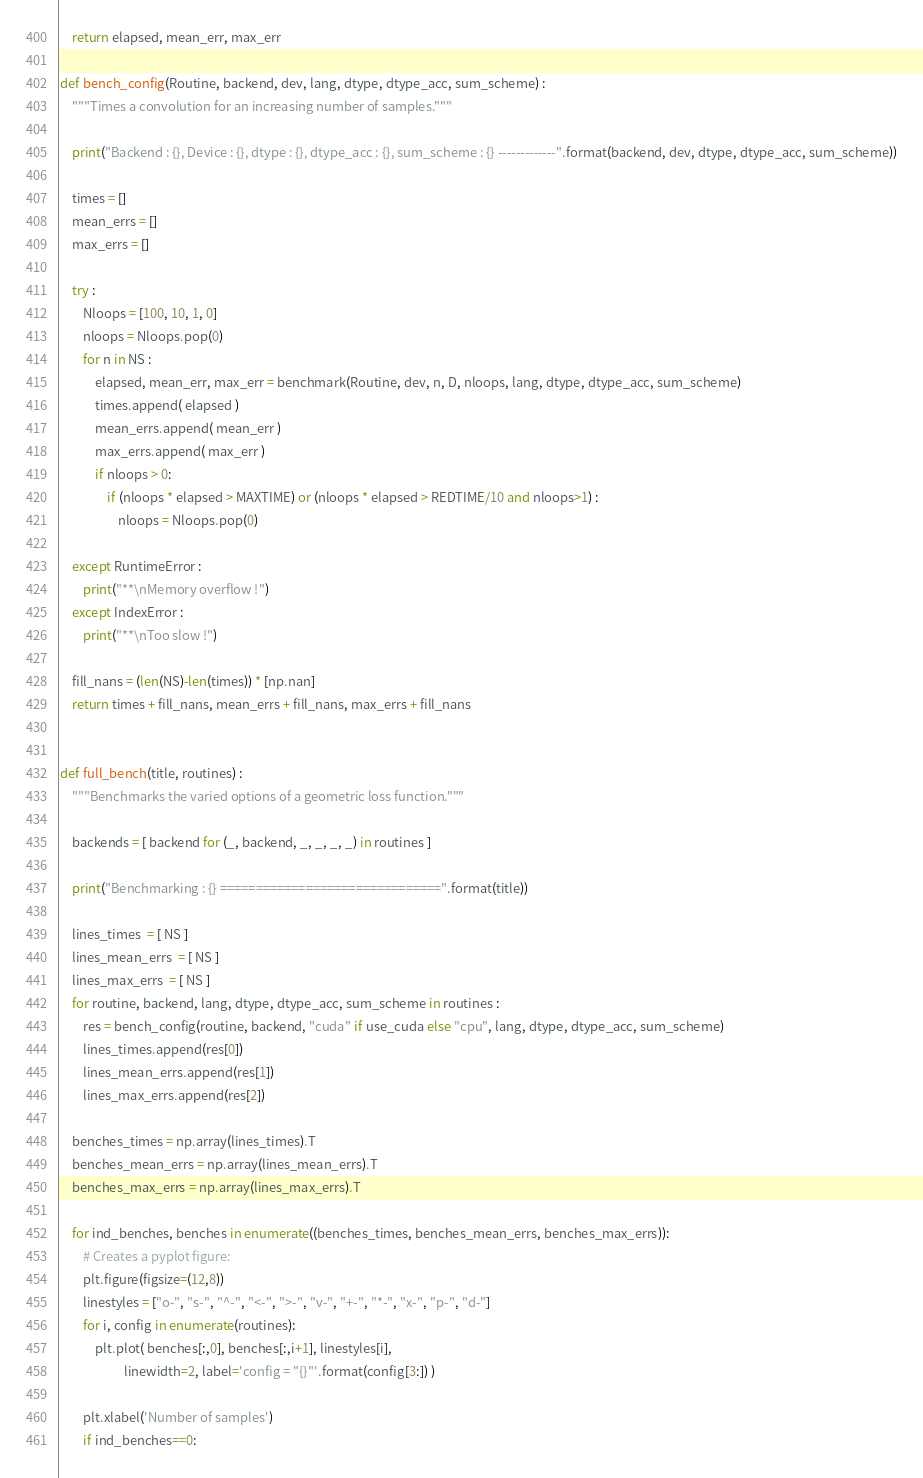Convert code to text. <code><loc_0><loc_0><loc_500><loc_500><_Python_>
    return elapsed, mean_err, max_err

def bench_config(Routine, backend, dev, lang, dtype, dtype_acc, sum_scheme) :
    """Times a convolution for an increasing number of samples."""

    print("Backend : {}, Device : {}, dtype : {}, dtype_acc : {}, sum_scheme : {} -------------".format(backend, dev, dtype, dtype_acc, sum_scheme))

    times = []
    mean_errs = []
    max_errs = []
            
    try :
        Nloops = [100, 10, 1, 0]
        nloops = Nloops.pop(0)
        for n in NS :
            elapsed, mean_err, max_err = benchmark(Routine, dev, n, D, nloops, lang, dtype, dtype_acc, sum_scheme)
            times.append( elapsed )
            mean_errs.append( mean_err )
            max_errs.append( max_err )
            if nloops > 0:
                if (nloops * elapsed > MAXTIME) or (nloops * elapsed > REDTIME/10 and nloops>1) : 
                    nloops = Nloops.pop(0)

    except RuntimeError :
        print("**\nMemory overflow !")
    except IndexError :
        print("**\nToo slow !")
    
    fill_nans = (len(NS)-len(times)) * [np.nan]
    return times + fill_nans, mean_errs + fill_nans, max_errs + fill_nans


def full_bench(title, routines) :
    """Benchmarks the varied options of a geometric loss function."""

    backends = [ backend for (_, backend, _, _, _, _) in routines ]

    print("Benchmarking : {} ===============================".format(title))
    
    lines_times  = [ NS ]
    lines_mean_errs  = [ NS ]
    lines_max_errs  = [ NS ]
    for routine, backend, lang, dtype, dtype_acc, sum_scheme in routines :
        res = bench_config(routine, backend, "cuda" if use_cuda else "cpu", lang, dtype, dtype_acc, sum_scheme)
        lines_times.append(res[0])
        lines_mean_errs.append(res[1])
        lines_max_errs.append(res[2])

    benches_times = np.array(lines_times).T
    benches_mean_errs = np.array(lines_mean_errs).T
    benches_max_errs = np.array(lines_max_errs).T

    for ind_benches, benches in enumerate((benches_times, benches_mean_errs, benches_max_errs)):
        # Creates a pyplot figure:
        plt.figure(figsize=(12,8))
        linestyles = ["o-", "s-", "^-", "<-", ">-", "v-", "+-", "*-", "x-", "p-", "d-"]
        for i, config in enumerate(routines):
            plt.plot( benches[:,0], benches[:,i+1], linestyles[i], 
                      linewidth=2, label='config = "{}"'.format(config[3:]) )
        
        plt.xlabel('Number of samples')
        if ind_benches==0:</code> 